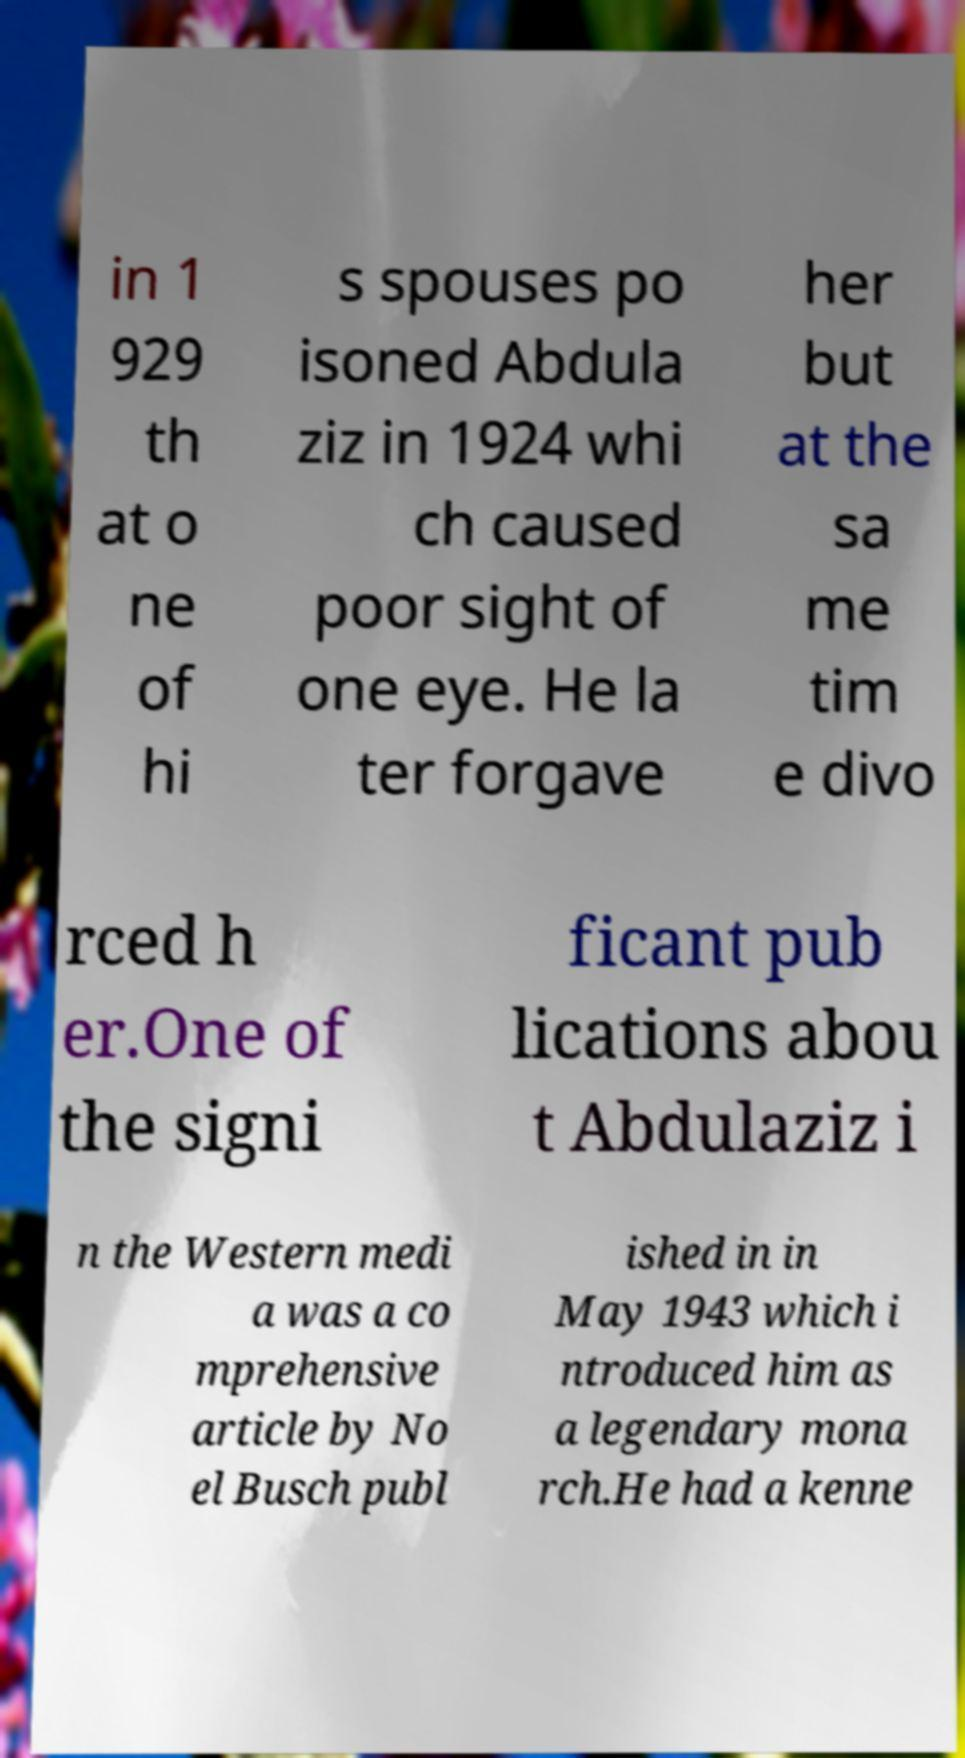I need the written content from this picture converted into text. Can you do that? in 1 929 th at o ne of hi s spouses po isoned Abdula ziz in 1924 whi ch caused poor sight of one eye. He la ter forgave her but at the sa me tim e divo rced h er.One of the signi ficant pub lications abou t Abdulaziz i n the Western medi a was a co mprehensive article by No el Busch publ ished in in May 1943 which i ntroduced him as a legendary mona rch.He had a kenne 